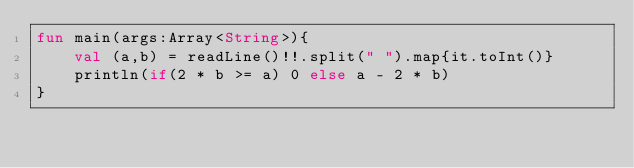<code> <loc_0><loc_0><loc_500><loc_500><_Kotlin_>fun main(args:Array<String>){
    val (a,b) = readLine()!!.split(" ").map{it.toInt()}
    println(if(2 * b >= a) 0 else a - 2 * b)
}</code> 